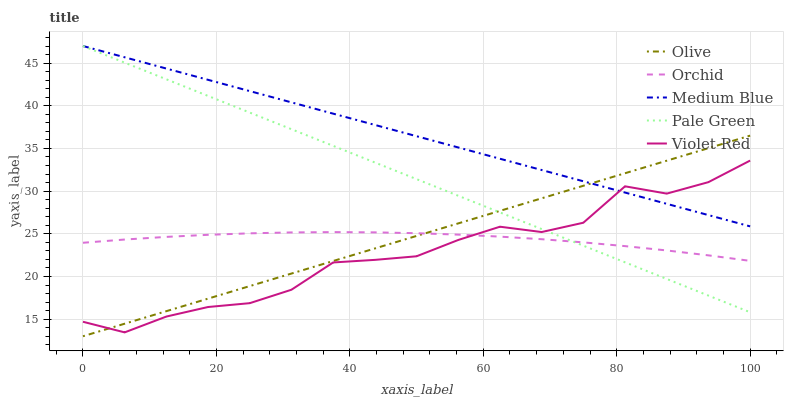Does Violet Red have the minimum area under the curve?
Answer yes or no. Yes. Does Medium Blue have the maximum area under the curve?
Answer yes or no. Yes. Does Pale Green have the minimum area under the curve?
Answer yes or no. No. Does Pale Green have the maximum area under the curve?
Answer yes or no. No. Is Olive the smoothest?
Answer yes or no. Yes. Is Violet Red the roughest?
Answer yes or no. Yes. Is Pale Green the smoothest?
Answer yes or no. No. Is Pale Green the roughest?
Answer yes or no. No. Does Violet Red have the lowest value?
Answer yes or no. No. Does Violet Red have the highest value?
Answer yes or no. No. Is Orchid less than Medium Blue?
Answer yes or no. Yes. Is Medium Blue greater than Orchid?
Answer yes or no. Yes. Does Orchid intersect Medium Blue?
Answer yes or no. No. 